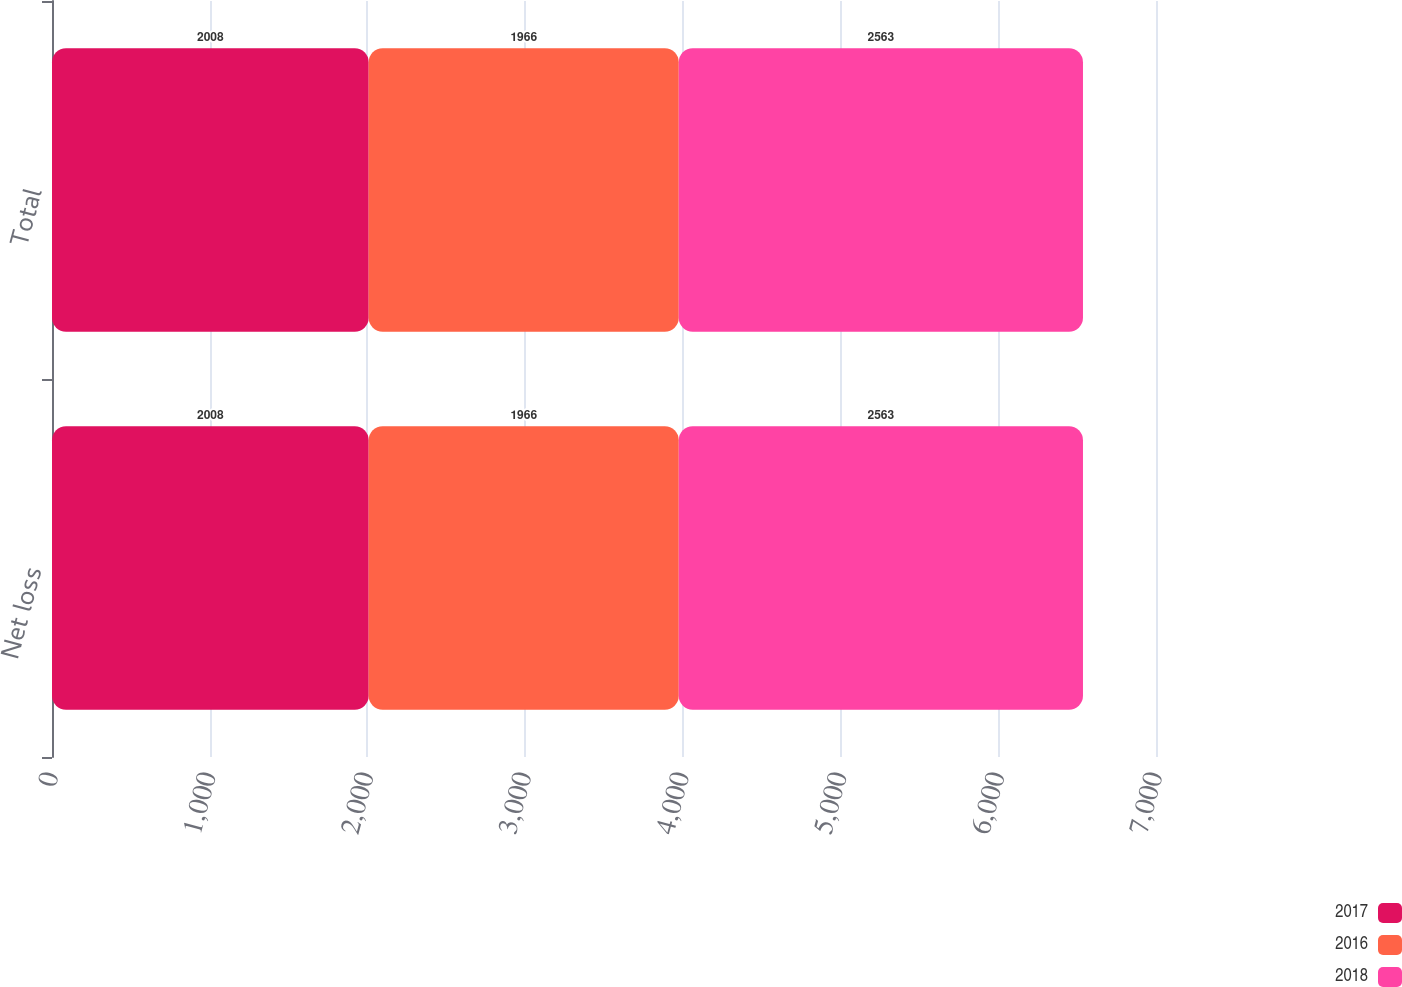Convert chart to OTSL. <chart><loc_0><loc_0><loc_500><loc_500><stacked_bar_chart><ecel><fcel>Net loss<fcel>Total<nl><fcel>2017<fcel>2008<fcel>2008<nl><fcel>2016<fcel>1966<fcel>1966<nl><fcel>2018<fcel>2563<fcel>2563<nl></chart> 